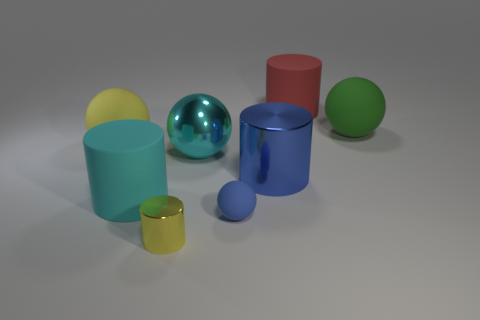Subtract all brown cylinders. Subtract all yellow spheres. How many cylinders are left? 4 Add 1 matte cylinders. How many objects exist? 9 Subtract all metal balls. Subtract all blue balls. How many objects are left? 6 Add 4 big cyan balls. How many big cyan balls are left? 5 Add 7 large cylinders. How many large cylinders exist? 10 Subtract 0 blue cubes. How many objects are left? 8 